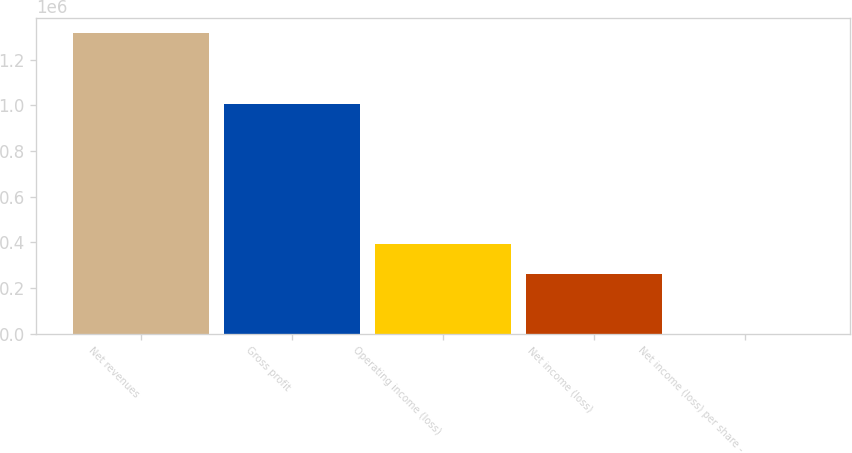<chart> <loc_0><loc_0><loc_500><loc_500><bar_chart><fcel>Net revenues<fcel>Gross profit<fcel>Operating income (loss)<fcel>Net income (loss)<fcel>Net income (loss) per share -<nl><fcel>1.31587e+06<fcel>1.00537e+06<fcel>394762<fcel>263175<fcel>0.12<nl></chart> 